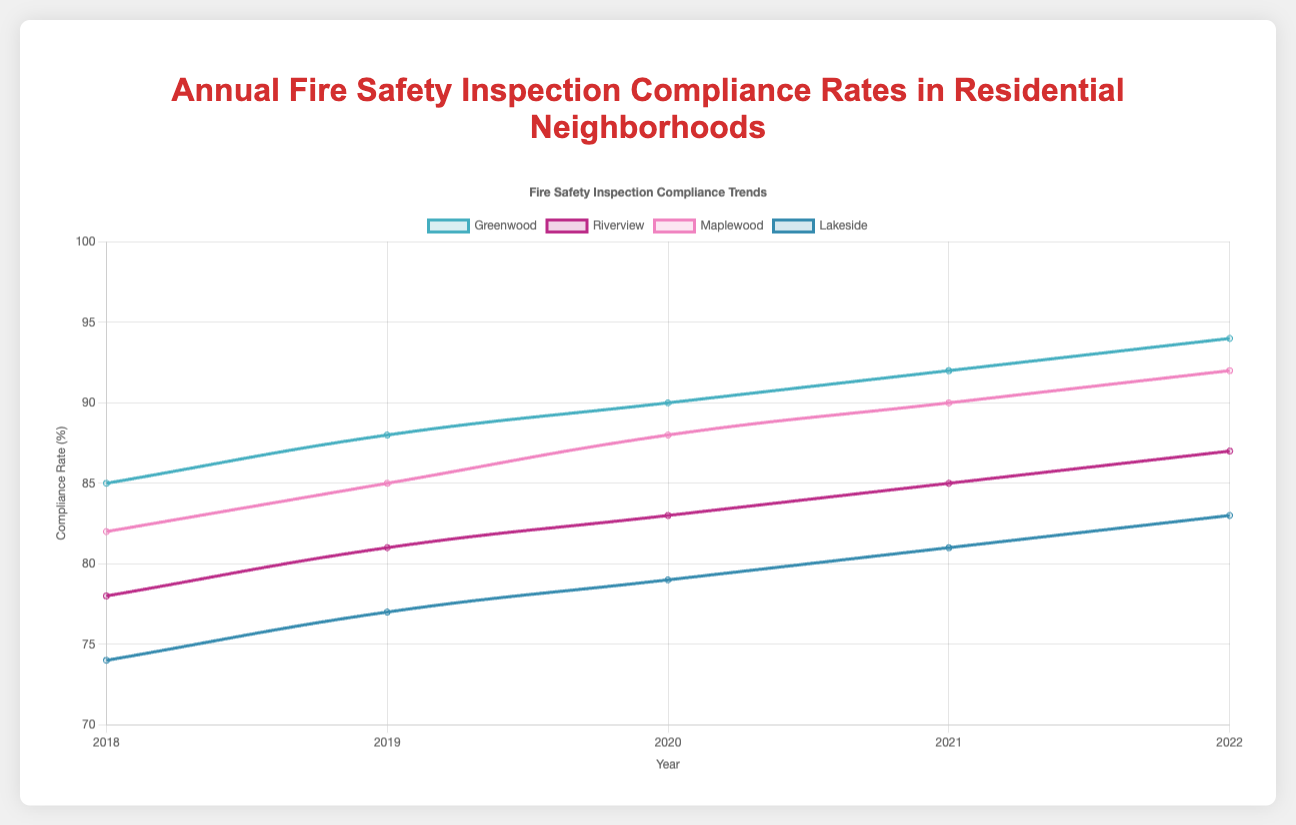Which neighborhood had the highest compliance rate in 2022? To find the neighborhood with the highest compliance rate in 2022, we look at the compliance rates for all neighborhoods in that year: Greenwood (94), Riverview (87), Maplewood (92), and Lakeside (83). The highest is Greenwood with a compliance rate of 94.
Answer: Greenwood Which year showed the greatest improvement in compliance rate for Maplewood? To determine the year with the greatest improvement for Maplewood, calculate the year-over-year differences: 2019 vs 2018 (85-82 = 3), 2020 vs 2019 (88-85 = 3), 2021 vs 2020 (90-88 = 2), 2022 vs 2021 (92-90 = 2). The greatest improvement is in 2019 and 2020, with an increase of 3 compliance points each.
Answer: 2019 and 2020 What is the average compliance rate for Greenwood between 2018 and 2022? To find the average compliance rate for Greenwood, sum the compliance rates from 2018 to 2022 (85 + 88 + 90 + 92 + 94 = 449) and divide by the number of years, which is 5: 449 / 5 = 89.8.
Answer: 89.8 Did Riverview's compliance rate increase every year from 2018 to 2022? Reviewing Riverview's compliance rates: 2018 (78), 2019 (81), 2020 (83), 2021 (85), 2022 (87), we see that the compliance rate increased every year.
Answer: Yes Which neighborhood had the lowest compliance rate in 2018 and what was it? Examining compliance rates for 2018, Greenwood (85), Riverview (78), Maplewood (82), Lakeside (74), the lowest rate was Lakeside with 74.
Answer: Lakeside, 74 Between 2020 and 2021, which neighborhood had the smallest increase in compliance rate? Calculating the changes in compliance rates from 2020 to 2021: Greenwood (92-90 = 2), Riverview (85-83 = 2), Maplewood (90-88 = 2), Lakeside (81-79 = 2), all neighborhoods had the same increase of 2.
Answer: All neighborhoods How did Lakeside's compliance rate change from 2018 to 2022? Looking at Lakeside's compliance rates over the years: 2018 (74), 2019 (77), 2020 (79), 2021 (81), 2022 (83), the rate increased sequentially, showing steady improvement each year.
Answer: Increased steadily What is the difference between Greenwood's highest and lowest compliance rates from 2018 to 2022? Greenwood's highest compliance rate is 94 (2022) and lowest is 85 (2018). The difference is 94 - 85 = 9.
Answer: 9 Comparing 2021 to 2022, which neighborhood had the largest increase in compliance rate? The increases from 2021 to 2022 are: Greenwood (94-92 = 2), Riverview (87-85 = 2), Maplewood (92-90 = 2), Lakeside (83-81 = 2). All neighborhoods had an increase of 2, meaning no single neighborhood had a larger increase than the others.
Answer: All neighborhoods 